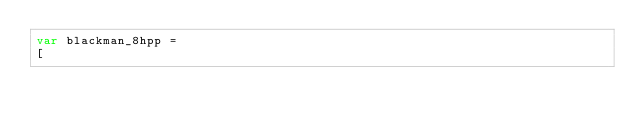Convert code to text. <code><loc_0><loc_0><loc_500><loc_500><_JavaScript_>var blackman_8hpp =
[</code> 